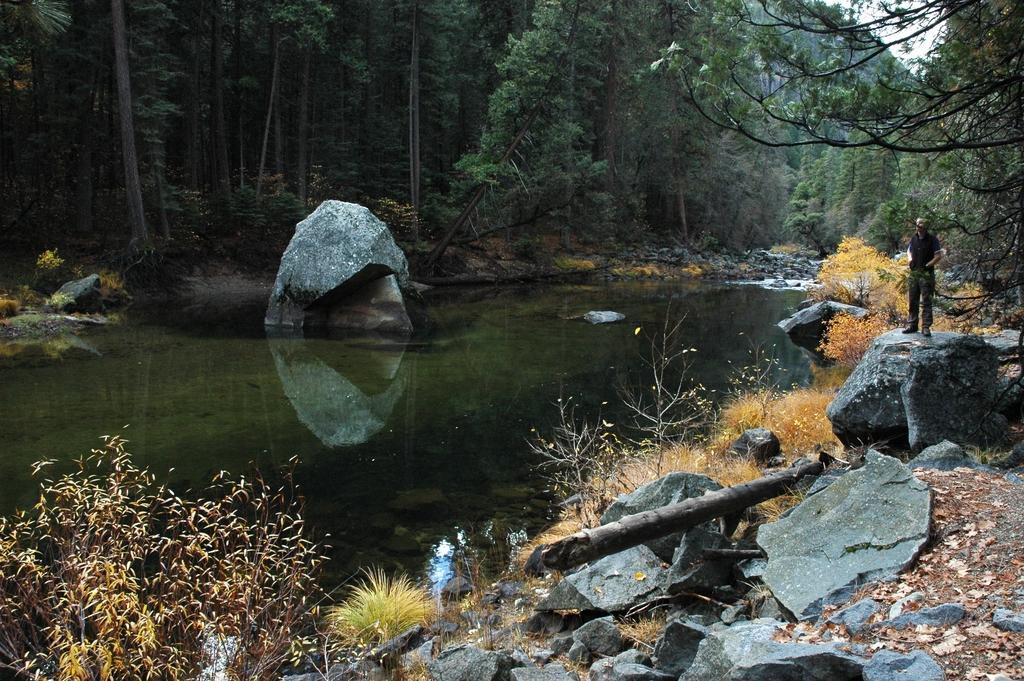In one or two sentences, can you explain what this image depicts? In this picture we can see water, grass, plants, and rocks. There is a person standing on the rock. In the background we can see trees and sky. 